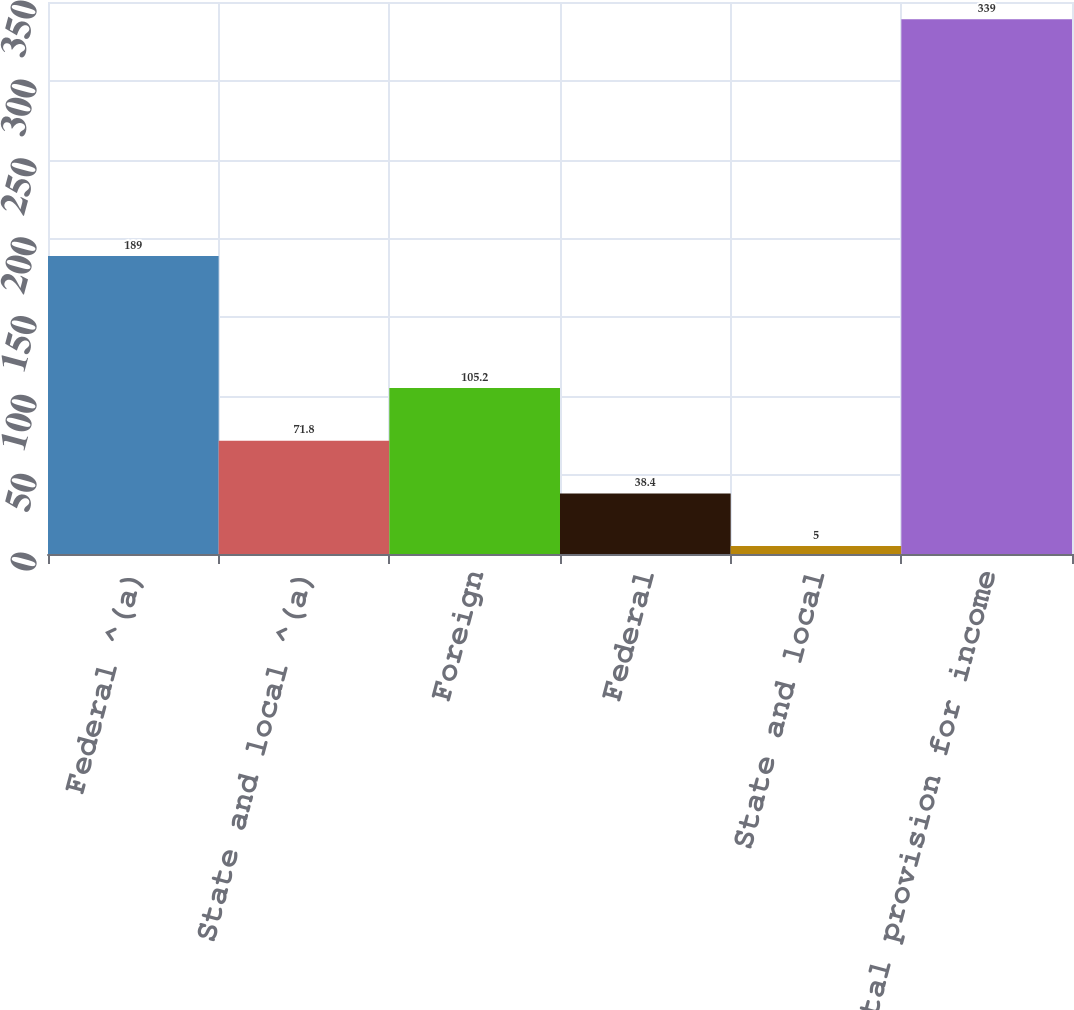Convert chart to OTSL. <chart><loc_0><loc_0><loc_500><loc_500><bar_chart><fcel>Federal ^(a)<fcel>State and local ^(a)<fcel>Foreign<fcel>Federal<fcel>State and local<fcel>Total provision for income<nl><fcel>189<fcel>71.8<fcel>105.2<fcel>38.4<fcel>5<fcel>339<nl></chart> 